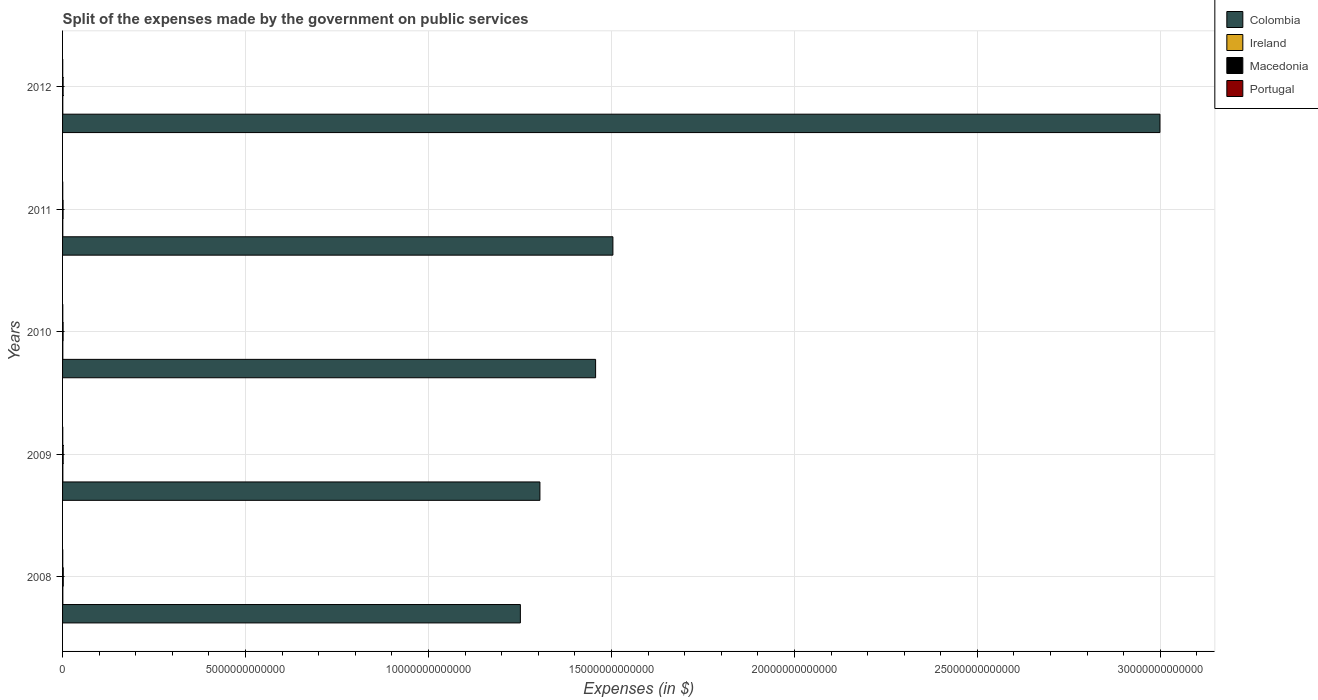Are the number of bars per tick equal to the number of legend labels?
Keep it short and to the point. Yes. How many bars are there on the 1st tick from the top?
Your answer should be very brief. 4. How many bars are there on the 3rd tick from the bottom?
Ensure brevity in your answer.  4. What is the label of the 2nd group of bars from the top?
Ensure brevity in your answer.  2011. In how many cases, is the number of bars for a given year not equal to the number of legend labels?
Keep it short and to the point. 0. What is the expenses made by the government on public services in Colombia in 2009?
Keep it short and to the point. 1.30e+13. Across all years, what is the maximum expenses made by the government on public services in Ireland?
Give a very brief answer. 7.87e+09. Across all years, what is the minimum expenses made by the government on public services in Colombia?
Your response must be concise. 1.25e+13. What is the total expenses made by the government on public services in Portugal in the graph?
Your answer should be very brief. 2.66e+1. What is the difference between the expenses made by the government on public services in Ireland in 2009 and that in 2011?
Provide a short and direct response. 1.45e+09. What is the difference between the expenses made by the government on public services in Ireland in 2009 and the expenses made by the government on public services in Colombia in 2012?
Make the answer very short. -3.00e+13. What is the average expenses made by the government on public services in Portugal per year?
Provide a short and direct response. 5.31e+09. In the year 2012, what is the difference between the expenses made by the government on public services in Colombia and expenses made by the government on public services in Macedonia?
Offer a very short reply. 3.00e+13. In how many years, is the expenses made by the government on public services in Portugal greater than 12000000000000 $?
Make the answer very short. 0. What is the ratio of the expenses made by the government on public services in Colombia in 2010 to that in 2011?
Provide a succinct answer. 0.97. What is the difference between the highest and the second highest expenses made by the government on public services in Portugal?
Ensure brevity in your answer.  6.00e+08. What is the difference between the highest and the lowest expenses made by the government on public services in Macedonia?
Make the answer very short. 4.79e+09. In how many years, is the expenses made by the government on public services in Portugal greater than the average expenses made by the government on public services in Portugal taken over all years?
Give a very brief answer. 2. Is the sum of the expenses made by the government on public services in Macedonia in 2008 and 2011 greater than the maximum expenses made by the government on public services in Colombia across all years?
Offer a terse response. No. Is it the case that in every year, the sum of the expenses made by the government on public services in Macedonia and expenses made by the government on public services in Colombia is greater than the sum of expenses made by the government on public services in Ireland and expenses made by the government on public services in Portugal?
Provide a succinct answer. Yes. What does the 4th bar from the bottom in 2009 represents?
Offer a terse response. Portugal. Is it the case that in every year, the sum of the expenses made by the government on public services in Colombia and expenses made by the government on public services in Ireland is greater than the expenses made by the government on public services in Macedonia?
Ensure brevity in your answer.  Yes. How many bars are there?
Provide a short and direct response. 20. Are all the bars in the graph horizontal?
Ensure brevity in your answer.  Yes. What is the difference between two consecutive major ticks on the X-axis?
Make the answer very short. 5.00e+12. Are the values on the major ticks of X-axis written in scientific E-notation?
Your answer should be compact. No. Does the graph contain any zero values?
Give a very brief answer. No. Does the graph contain grids?
Offer a very short reply. Yes. How many legend labels are there?
Your answer should be compact. 4. How are the legend labels stacked?
Your answer should be very brief. Vertical. What is the title of the graph?
Provide a short and direct response. Split of the expenses made by the government on public services. Does "Portugal" appear as one of the legend labels in the graph?
Provide a short and direct response. Yes. What is the label or title of the X-axis?
Keep it short and to the point. Expenses (in $). What is the Expenses (in $) of Colombia in 2008?
Give a very brief answer. 1.25e+13. What is the Expenses (in $) of Ireland in 2008?
Give a very brief answer. 7.59e+09. What is the Expenses (in $) of Macedonia in 2008?
Offer a very short reply. 1.87e+1. What is the Expenses (in $) of Portugal in 2008?
Your response must be concise. 4.99e+09. What is the Expenses (in $) of Colombia in 2009?
Your answer should be very brief. 1.30e+13. What is the Expenses (in $) in Ireland in 2009?
Your answer should be compact. 7.87e+09. What is the Expenses (in $) in Macedonia in 2009?
Keep it short and to the point. 1.62e+1. What is the Expenses (in $) of Portugal in 2009?
Offer a very short reply. 5.51e+09. What is the Expenses (in $) in Colombia in 2010?
Your response must be concise. 1.46e+13. What is the Expenses (in $) of Ireland in 2010?
Give a very brief answer. 7.05e+09. What is the Expenses (in $) in Macedonia in 2010?
Ensure brevity in your answer.  1.47e+1. What is the Expenses (in $) in Portugal in 2010?
Provide a succinct answer. 6.12e+09. What is the Expenses (in $) of Colombia in 2011?
Provide a short and direct response. 1.50e+13. What is the Expenses (in $) in Ireland in 2011?
Keep it short and to the point. 6.42e+09. What is the Expenses (in $) in Macedonia in 2011?
Ensure brevity in your answer.  1.40e+1. What is the Expenses (in $) of Portugal in 2011?
Make the answer very short. 5.18e+09. What is the Expenses (in $) in Colombia in 2012?
Ensure brevity in your answer.  3.00e+13. What is the Expenses (in $) of Ireland in 2012?
Give a very brief answer. 6.16e+09. What is the Expenses (in $) of Macedonia in 2012?
Give a very brief answer. 1.47e+1. What is the Expenses (in $) in Portugal in 2012?
Ensure brevity in your answer.  4.76e+09. Across all years, what is the maximum Expenses (in $) in Colombia?
Give a very brief answer. 3.00e+13. Across all years, what is the maximum Expenses (in $) of Ireland?
Make the answer very short. 7.87e+09. Across all years, what is the maximum Expenses (in $) of Macedonia?
Provide a succinct answer. 1.87e+1. Across all years, what is the maximum Expenses (in $) of Portugal?
Make the answer very short. 6.12e+09. Across all years, what is the minimum Expenses (in $) of Colombia?
Your response must be concise. 1.25e+13. Across all years, what is the minimum Expenses (in $) of Ireland?
Your response must be concise. 6.16e+09. Across all years, what is the minimum Expenses (in $) in Macedonia?
Ensure brevity in your answer.  1.40e+1. Across all years, what is the minimum Expenses (in $) in Portugal?
Offer a very short reply. 4.76e+09. What is the total Expenses (in $) in Colombia in the graph?
Your response must be concise. 8.52e+13. What is the total Expenses (in $) in Ireland in the graph?
Give a very brief answer. 3.51e+1. What is the total Expenses (in $) in Macedonia in the graph?
Offer a very short reply. 7.83e+1. What is the total Expenses (in $) of Portugal in the graph?
Your response must be concise. 2.66e+1. What is the difference between the Expenses (in $) of Colombia in 2008 and that in 2009?
Make the answer very short. -5.34e+11. What is the difference between the Expenses (in $) of Ireland in 2008 and that in 2009?
Provide a short and direct response. -2.79e+08. What is the difference between the Expenses (in $) of Macedonia in 2008 and that in 2009?
Offer a terse response. 2.52e+09. What is the difference between the Expenses (in $) in Portugal in 2008 and that in 2009?
Make the answer very short. -5.27e+08. What is the difference between the Expenses (in $) of Colombia in 2008 and that in 2010?
Give a very brief answer. -2.06e+12. What is the difference between the Expenses (in $) in Ireland in 2008 and that in 2010?
Your response must be concise. 5.35e+08. What is the difference between the Expenses (in $) in Macedonia in 2008 and that in 2010?
Your response must be concise. 4.06e+09. What is the difference between the Expenses (in $) of Portugal in 2008 and that in 2010?
Keep it short and to the point. -1.13e+09. What is the difference between the Expenses (in $) in Colombia in 2008 and that in 2011?
Offer a terse response. -2.53e+12. What is the difference between the Expenses (in $) of Ireland in 2008 and that in 2011?
Provide a short and direct response. 1.17e+09. What is the difference between the Expenses (in $) in Macedonia in 2008 and that in 2011?
Give a very brief answer. 4.79e+09. What is the difference between the Expenses (in $) in Portugal in 2008 and that in 2011?
Give a very brief answer. -1.91e+08. What is the difference between the Expenses (in $) of Colombia in 2008 and that in 2012?
Provide a succinct answer. -1.75e+13. What is the difference between the Expenses (in $) of Ireland in 2008 and that in 2012?
Your answer should be compact. 1.43e+09. What is the difference between the Expenses (in $) in Macedonia in 2008 and that in 2012?
Your response must be concise. 4.09e+09. What is the difference between the Expenses (in $) in Portugal in 2008 and that in 2012?
Make the answer very short. 2.23e+08. What is the difference between the Expenses (in $) in Colombia in 2009 and that in 2010?
Offer a very short reply. -1.52e+12. What is the difference between the Expenses (in $) of Ireland in 2009 and that in 2010?
Provide a succinct answer. 8.15e+08. What is the difference between the Expenses (in $) of Macedonia in 2009 and that in 2010?
Provide a short and direct response. 1.54e+09. What is the difference between the Expenses (in $) of Portugal in 2009 and that in 2010?
Your response must be concise. -6.00e+08. What is the difference between the Expenses (in $) of Colombia in 2009 and that in 2011?
Provide a succinct answer. -1.99e+12. What is the difference between the Expenses (in $) of Ireland in 2009 and that in 2011?
Keep it short and to the point. 1.45e+09. What is the difference between the Expenses (in $) in Macedonia in 2009 and that in 2011?
Offer a very short reply. 2.26e+09. What is the difference between the Expenses (in $) in Portugal in 2009 and that in 2011?
Offer a very short reply. 3.36e+08. What is the difference between the Expenses (in $) in Colombia in 2009 and that in 2012?
Offer a very short reply. -1.69e+13. What is the difference between the Expenses (in $) in Ireland in 2009 and that in 2012?
Keep it short and to the point. 1.71e+09. What is the difference between the Expenses (in $) in Macedonia in 2009 and that in 2012?
Your response must be concise. 1.57e+09. What is the difference between the Expenses (in $) in Portugal in 2009 and that in 2012?
Your answer should be compact. 7.51e+08. What is the difference between the Expenses (in $) in Colombia in 2010 and that in 2011?
Your response must be concise. -4.73e+11. What is the difference between the Expenses (in $) in Ireland in 2010 and that in 2011?
Keep it short and to the point. 6.31e+08. What is the difference between the Expenses (in $) in Macedonia in 2010 and that in 2011?
Offer a very short reply. 7.23e+08. What is the difference between the Expenses (in $) in Portugal in 2010 and that in 2011?
Ensure brevity in your answer.  9.36e+08. What is the difference between the Expenses (in $) in Colombia in 2010 and that in 2012?
Your response must be concise. -1.54e+13. What is the difference between the Expenses (in $) of Ireland in 2010 and that in 2012?
Keep it short and to the point. 8.94e+08. What is the difference between the Expenses (in $) in Macedonia in 2010 and that in 2012?
Provide a short and direct response. 2.90e+07. What is the difference between the Expenses (in $) in Portugal in 2010 and that in 2012?
Provide a short and direct response. 1.35e+09. What is the difference between the Expenses (in $) of Colombia in 2011 and that in 2012?
Ensure brevity in your answer.  -1.49e+13. What is the difference between the Expenses (in $) of Ireland in 2011 and that in 2012?
Keep it short and to the point. 2.63e+08. What is the difference between the Expenses (in $) in Macedonia in 2011 and that in 2012?
Offer a very short reply. -6.94e+08. What is the difference between the Expenses (in $) of Portugal in 2011 and that in 2012?
Offer a very short reply. 4.15e+08. What is the difference between the Expenses (in $) of Colombia in 2008 and the Expenses (in $) of Ireland in 2009?
Offer a terse response. 1.25e+13. What is the difference between the Expenses (in $) of Colombia in 2008 and the Expenses (in $) of Macedonia in 2009?
Make the answer very short. 1.25e+13. What is the difference between the Expenses (in $) in Colombia in 2008 and the Expenses (in $) in Portugal in 2009?
Make the answer very short. 1.25e+13. What is the difference between the Expenses (in $) in Ireland in 2008 and the Expenses (in $) in Macedonia in 2009?
Provide a short and direct response. -8.63e+09. What is the difference between the Expenses (in $) in Ireland in 2008 and the Expenses (in $) in Portugal in 2009?
Your answer should be compact. 2.07e+09. What is the difference between the Expenses (in $) in Macedonia in 2008 and the Expenses (in $) in Portugal in 2009?
Ensure brevity in your answer.  1.32e+1. What is the difference between the Expenses (in $) of Colombia in 2008 and the Expenses (in $) of Ireland in 2010?
Make the answer very short. 1.25e+13. What is the difference between the Expenses (in $) of Colombia in 2008 and the Expenses (in $) of Macedonia in 2010?
Provide a succinct answer. 1.25e+13. What is the difference between the Expenses (in $) of Colombia in 2008 and the Expenses (in $) of Portugal in 2010?
Provide a succinct answer. 1.25e+13. What is the difference between the Expenses (in $) of Ireland in 2008 and the Expenses (in $) of Macedonia in 2010?
Ensure brevity in your answer.  -7.10e+09. What is the difference between the Expenses (in $) of Ireland in 2008 and the Expenses (in $) of Portugal in 2010?
Keep it short and to the point. 1.47e+09. What is the difference between the Expenses (in $) in Macedonia in 2008 and the Expenses (in $) in Portugal in 2010?
Give a very brief answer. 1.26e+1. What is the difference between the Expenses (in $) in Colombia in 2008 and the Expenses (in $) in Ireland in 2011?
Your answer should be compact. 1.25e+13. What is the difference between the Expenses (in $) of Colombia in 2008 and the Expenses (in $) of Macedonia in 2011?
Provide a succinct answer. 1.25e+13. What is the difference between the Expenses (in $) in Colombia in 2008 and the Expenses (in $) in Portugal in 2011?
Make the answer very short. 1.25e+13. What is the difference between the Expenses (in $) in Ireland in 2008 and the Expenses (in $) in Macedonia in 2011?
Provide a succinct answer. -6.37e+09. What is the difference between the Expenses (in $) of Ireland in 2008 and the Expenses (in $) of Portugal in 2011?
Make the answer very short. 2.41e+09. What is the difference between the Expenses (in $) of Macedonia in 2008 and the Expenses (in $) of Portugal in 2011?
Your answer should be very brief. 1.36e+1. What is the difference between the Expenses (in $) of Colombia in 2008 and the Expenses (in $) of Ireland in 2012?
Your answer should be compact. 1.25e+13. What is the difference between the Expenses (in $) of Colombia in 2008 and the Expenses (in $) of Macedonia in 2012?
Provide a short and direct response. 1.25e+13. What is the difference between the Expenses (in $) of Colombia in 2008 and the Expenses (in $) of Portugal in 2012?
Offer a very short reply. 1.25e+13. What is the difference between the Expenses (in $) of Ireland in 2008 and the Expenses (in $) of Macedonia in 2012?
Provide a short and direct response. -7.07e+09. What is the difference between the Expenses (in $) of Ireland in 2008 and the Expenses (in $) of Portugal in 2012?
Your answer should be compact. 2.82e+09. What is the difference between the Expenses (in $) in Macedonia in 2008 and the Expenses (in $) in Portugal in 2012?
Make the answer very short. 1.40e+1. What is the difference between the Expenses (in $) of Colombia in 2009 and the Expenses (in $) of Ireland in 2010?
Give a very brief answer. 1.30e+13. What is the difference between the Expenses (in $) in Colombia in 2009 and the Expenses (in $) in Macedonia in 2010?
Offer a very short reply. 1.30e+13. What is the difference between the Expenses (in $) of Colombia in 2009 and the Expenses (in $) of Portugal in 2010?
Offer a terse response. 1.30e+13. What is the difference between the Expenses (in $) in Ireland in 2009 and the Expenses (in $) in Macedonia in 2010?
Give a very brief answer. -6.82e+09. What is the difference between the Expenses (in $) of Ireland in 2009 and the Expenses (in $) of Portugal in 2010?
Offer a very short reply. 1.75e+09. What is the difference between the Expenses (in $) of Macedonia in 2009 and the Expenses (in $) of Portugal in 2010?
Your response must be concise. 1.01e+1. What is the difference between the Expenses (in $) of Colombia in 2009 and the Expenses (in $) of Ireland in 2011?
Your answer should be very brief. 1.30e+13. What is the difference between the Expenses (in $) in Colombia in 2009 and the Expenses (in $) in Macedonia in 2011?
Your answer should be very brief. 1.30e+13. What is the difference between the Expenses (in $) of Colombia in 2009 and the Expenses (in $) of Portugal in 2011?
Your answer should be compact. 1.30e+13. What is the difference between the Expenses (in $) in Ireland in 2009 and the Expenses (in $) in Macedonia in 2011?
Ensure brevity in your answer.  -6.09e+09. What is the difference between the Expenses (in $) of Ireland in 2009 and the Expenses (in $) of Portugal in 2011?
Your response must be concise. 2.69e+09. What is the difference between the Expenses (in $) of Macedonia in 2009 and the Expenses (in $) of Portugal in 2011?
Keep it short and to the point. 1.10e+1. What is the difference between the Expenses (in $) in Colombia in 2009 and the Expenses (in $) in Ireland in 2012?
Give a very brief answer. 1.30e+13. What is the difference between the Expenses (in $) of Colombia in 2009 and the Expenses (in $) of Macedonia in 2012?
Offer a very short reply. 1.30e+13. What is the difference between the Expenses (in $) in Colombia in 2009 and the Expenses (in $) in Portugal in 2012?
Provide a succinct answer. 1.30e+13. What is the difference between the Expenses (in $) in Ireland in 2009 and the Expenses (in $) in Macedonia in 2012?
Your answer should be very brief. -6.79e+09. What is the difference between the Expenses (in $) of Ireland in 2009 and the Expenses (in $) of Portugal in 2012?
Your answer should be compact. 3.10e+09. What is the difference between the Expenses (in $) in Macedonia in 2009 and the Expenses (in $) in Portugal in 2012?
Provide a short and direct response. 1.15e+1. What is the difference between the Expenses (in $) in Colombia in 2010 and the Expenses (in $) in Ireland in 2011?
Give a very brief answer. 1.46e+13. What is the difference between the Expenses (in $) in Colombia in 2010 and the Expenses (in $) in Macedonia in 2011?
Keep it short and to the point. 1.46e+13. What is the difference between the Expenses (in $) of Colombia in 2010 and the Expenses (in $) of Portugal in 2011?
Ensure brevity in your answer.  1.46e+13. What is the difference between the Expenses (in $) of Ireland in 2010 and the Expenses (in $) of Macedonia in 2011?
Keep it short and to the point. -6.91e+09. What is the difference between the Expenses (in $) of Ireland in 2010 and the Expenses (in $) of Portugal in 2011?
Offer a very short reply. 1.87e+09. What is the difference between the Expenses (in $) in Macedonia in 2010 and the Expenses (in $) in Portugal in 2011?
Offer a terse response. 9.50e+09. What is the difference between the Expenses (in $) in Colombia in 2010 and the Expenses (in $) in Ireland in 2012?
Your answer should be very brief. 1.46e+13. What is the difference between the Expenses (in $) in Colombia in 2010 and the Expenses (in $) in Macedonia in 2012?
Provide a short and direct response. 1.46e+13. What is the difference between the Expenses (in $) in Colombia in 2010 and the Expenses (in $) in Portugal in 2012?
Offer a very short reply. 1.46e+13. What is the difference between the Expenses (in $) of Ireland in 2010 and the Expenses (in $) of Macedonia in 2012?
Give a very brief answer. -7.60e+09. What is the difference between the Expenses (in $) in Ireland in 2010 and the Expenses (in $) in Portugal in 2012?
Your response must be concise. 2.29e+09. What is the difference between the Expenses (in $) of Macedonia in 2010 and the Expenses (in $) of Portugal in 2012?
Keep it short and to the point. 9.92e+09. What is the difference between the Expenses (in $) in Colombia in 2011 and the Expenses (in $) in Ireland in 2012?
Your answer should be very brief. 1.50e+13. What is the difference between the Expenses (in $) in Colombia in 2011 and the Expenses (in $) in Macedonia in 2012?
Ensure brevity in your answer.  1.50e+13. What is the difference between the Expenses (in $) of Colombia in 2011 and the Expenses (in $) of Portugal in 2012?
Make the answer very short. 1.50e+13. What is the difference between the Expenses (in $) in Ireland in 2011 and the Expenses (in $) in Macedonia in 2012?
Offer a very short reply. -8.23e+09. What is the difference between the Expenses (in $) in Ireland in 2011 and the Expenses (in $) in Portugal in 2012?
Ensure brevity in your answer.  1.66e+09. What is the difference between the Expenses (in $) in Macedonia in 2011 and the Expenses (in $) in Portugal in 2012?
Provide a short and direct response. 9.19e+09. What is the average Expenses (in $) in Colombia per year?
Provide a succinct answer. 1.70e+13. What is the average Expenses (in $) in Ireland per year?
Your answer should be compact. 7.02e+09. What is the average Expenses (in $) in Macedonia per year?
Provide a succinct answer. 1.57e+1. What is the average Expenses (in $) in Portugal per year?
Offer a very short reply. 5.31e+09. In the year 2008, what is the difference between the Expenses (in $) in Colombia and Expenses (in $) in Ireland?
Your answer should be compact. 1.25e+13. In the year 2008, what is the difference between the Expenses (in $) of Colombia and Expenses (in $) of Macedonia?
Provide a succinct answer. 1.25e+13. In the year 2008, what is the difference between the Expenses (in $) of Colombia and Expenses (in $) of Portugal?
Your answer should be very brief. 1.25e+13. In the year 2008, what is the difference between the Expenses (in $) in Ireland and Expenses (in $) in Macedonia?
Provide a short and direct response. -1.12e+1. In the year 2008, what is the difference between the Expenses (in $) of Ireland and Expenses (in $) of Portugal?
Give a very brief answer. 2.60e+09. In the year 2008, what is the difference between the Expenses (in $) in Macedonia and Expenses (in $) in Portugal?
Give a very brief answer. 1.38e+1. In the year 2009, what is the difference between the Expenses (in $) of Colombia and Expenses (in $) of Ireland?
Offer a very short reply. 1.30e+13. In the year 2009, what is the difference between the Expenses (in $) in Colombia and Expenses (in $) in Macedonia?
Your answer should be compact. 1.30e+13. In the year 2009, what is the difference between the Expenses (in $) in Colombia and Expenses (in $) in Portugal?
Keep it short and to the point. 1.30e+13. In the year 2009, what is the difference between the Expenses (in $) in Ireland and Expenses (in $) in Macedonia?
Provide a succinct answer. -8.35e+09. In the year 2009, what is the difference between the Expenses (in $) of Ireland and Expenses (in $) of Portugal?
Give a very brief answer. 2.35e+09. In the year 2009, what is the difference between the Expenses (in $) of Macedonia and Expenses (in $) of Portugal?
Give a very brief answer. 1.07e+1. In the year 2010, what is the difference between the Expenses (in $) in Colombia and Expenses (in $) in Ireland?
Ensure brevity in your answer.  1.46e+13. In the year 2010, what is the difference between the Expenses (in $) of Colombia and Expenses (in $) of Macedonia?
Your answer should be very brief. 1.46e+13. In the year 2010, what is the difference between the Expenses (in $) of Colombia and Expenses (in $) of Portugal?
Give a very brief answer. 1.46e+13. In the year 2010, what is the difference between the Expenses (in $) of Ireland and Expenses (in $) of Macedonia?
Your answer should be very brief. -7.63e+09. In the year 2010, what is the difference between the Expenses (in $) of Ireland and Expenses (in $) of Portugal?
Offer a very short reply. 9.35e+08. In the year 2010, what is the difference between the Expenses (in $) in Macedonia and Expenses (in $) in Portugal?
Provide a succinct answer. 8.57e+09. In the year 2011, what is the difference between the Expenses (in $) in Colombia and Expenses (in $) in Ireland?
Ensure brevity in your answer.  1.50e+13. In the year 2011, what is the difference between the Expenses (in $) in Colombia and Expenses (in $) in Macedonia?
Keep it short and to the point. 1.50e+13. In the year 2011, what is the difference between the Expenses (in $) of Colombia and Expenses (in $) of Portugal?
Make the answer very short. 1.50e+13. In the year 2011, what is the difference between the Expenses (in $) in Ireland and Expenses (in $) in Macedonia?
Your answer should be very brief. -7.54e+09. In the year 2011, what is the difference between the Expenses (in $) in Ireland and Expenses (in $) in Portugal?
Your answer should be very brief. 1.24e+09. In the year 2011, what is the difference between the Expenses (in $) in Macedonia and Expenses (in $) in Portugal?
Make the answer very short. 8.78e+09. In the year 2012, what is the difference between the Expenses (in $) of Colombia and Expenses (in $) of Ireland?
Offer a very short reply. 3.00e+13. In the year 2012, what is the difference between the Expenses (in $) in Colombia and Expenses (in $) in Macedonia?
Offer a very short reply. 3.00e+13. In the year 2012, what is the difference between the Expenses (in $) of Colombia and Expenses (in $) of Portugal?
Ensure brevity in your answer.  3.00e+13. In the year 2012, what is the difference between the Expenses (in $) in Ireland and Expenses (in $) in Macedonia?
Offer a terse response. -8.50e+09. In the year 2012, what is the difference between the Expenses (in $) of Ireland and Expenses (in $) of Portugal?
Your answer should be compact. 1.39e+09. In the year 2012, what is the difference between the Expenses (in $) of Macedonia and Expenses (in $) of Portugal?
Offer a terse response. 9.89e+09. What is the ratio of the Expenses (in $) of Colombia in 2008 to that in 2009?
Give a very brief answer. 0.96. What is the ratio of the Expenses (in $) of Ireland in 2008 to that in 2009?
Provide a short and direct response. 0.96. What is the ratio of the Expenses (in $) of Macedonia in 2008 to that in 2009?
Your answer should be compact. 1.16. What is the ratio of the Expenses (in $) of Portugal in 2008 to that in 2009?
Make the answer very short. 0.9. What is the ratio of the Expenses (in $) of Colombia in 2008 to that in 2010?
Offer a very short reply. 0.86. What is the ratio of the Expenses (in $) of Ireland in 2008 to that in 2010?
Keep it short and to the point. 1.08. What is the ratio of the Expenses (in $) in Macedonia in 2008 to that in 2010?
Provide a short and direct response. 1.28. What is the ratio of the Expenses (in $) of Portugal in 2008 to that in 2010?
Offer a terse response. 0.82. What is the ratio of the Expenses (in $) of Colombia in 2008 to that in 2011?
Your response must be concise. 0.83. What is the ratio of the Expenses (in $) in Ireland in 2008 to that in 2011?
Keep it short and to the point. 1.18. What is the ratio of the Expenses (in $) of Macedonia in 2008 to that in 2011?
Keep it short and to the point. 1.34. What is the ratio of the Expenses (in $) of Portugal in 2008 to that in 2011?
Offer a very short reply. 0.96. What is the ratio of the Expenses (in $) of Colombia in 2008 to that in 2012?
Your answer should be very brief. 0.42. What is the ratio of the Expenses (in $) in Ireland in 2008 to that in 2012?
Your response must be concise. 1.23. What is the ratio of the Expenses (in $) in Macedonia in 2008 to that in 2012?
Offer a terse response. 1.28. What is the ratio of the Expenses (in $) in Portugal in 2008 to that in 2012?
Provide a short and direct response. 1.05. What is the ratio of the Expenses (in $) of Colombia in 2009 to that in 2010?
Provide a succinct answer. 0.9. What is the ratio of the Expenses (in $) in Ireland in 2009 to that in 2010?
Your response must be concise. 1.12. What is the ratio of the Expenses (in $) of Macedonia in 2009 to that in 2010?
Give a very brief answer. 1.1. What is the ratio of the Expenses (in $) of Portugal in 2009 to that in 2010?
Make the answer very short. 0.9. What is the ratio of the Expenses (in $) in Colombia in 2009 to that in 2011?
Keep it short and to the point. 0.87. What is the ratio of the Expenses (in $) of Ireland in 2009 to that in 2011?
Your response must be concise. 1.23. What is the ratio of the Expenses (in $) in Macedonia in 2009 to that in 2011?
Ensure brevity in your answer.  1.16. What is the ratio of the Expenses (in $) in Portugal in 2009 to that in 2011?
Ensure brevity in your answer.  1.06. What is the ratio of the Expenses (in $) in Colombia in 2009 to that in 2012?
Provide a succinct answer. 0.43. What is the ratio of the Expenses (in $) of Ireland in 2009 to that in 2012?
Your response must be concise. 1.28. What is the ratio of the Expenses (in $) in Macedonia in 2009 to that in 2012?
Your answer should be very brief. 1.11. What is the ratio of the Expenses (in $) of Portugal in 2009 to that in 2012?
Keep it short and to the point. 1.16. What is the ratio of the Expenses (in $) of Colombia in 2010 to that in 2011?
Provide a short and direct response. 0.97. What is the ratio of the Expenses (in $) of Ireland in 2010 to that in 2011?
Your answer should be compact. 1.1. What is the ratio of the Expenses (in $) in Macedonia in 2010 to that in 2011?
Give a very brief answer. 1.05. What is the ratio of the Expenses (in $) of Portugal in 2010 to that in 2011?
Ensure brevity in your answer.  1.18. What is the ratio of the Expenses (in $) in Colombia in 2010 to that in 2012?
Provide a succinct answer. 0.49. What is the ratio of the Expenses (in $) in Ireland in 2010 to that in 2012?
Provide a succinct answer. 1.15. What is the ratio of the Expenses (in $) of Macedonia in 2010 to that in 2012?
Provide a succinct answer. 1. What is the ratio of the Expenses (in $) in Portugal in 2010 to that in 2012?
Your response must be concise. 1.28. What is the ratio of the Expenses (in $) in Colombia in 2011 to that in 2012?
Provide a short and direct response. 0.5. What is the ratio of the Expenses (in $) in Ireland in 2011 to that in 2012?
Provide a succinct answer. 1.04. What is the ratio of the Expenses (in $) in Macedonia in 2011 to that in 2012?
Provide a succinct answer. 0.95. What is the ratio of the Expenses (in $) of Portugal in 2011 to that in 2012?
Offer a very short reply. 1.09. What is the difference between the highest and the second highest Expenses (in $) of Colombia?
Your answer should be compact. 1.49e+13. What is the difference between the highest and the second highest Expenses (in $) in Ireland?
Offer a terse response. 2.79e+08. What is the difference between the highest and the second highest Expenses (in $) in Macedonia?
Provide a succinct answer. 2.52e+09. What is the difference between the highest and the second highest Expenses (in $) of Portugal?
Keep it short and to the point. 6.00e+08. What is the difference between the highest and the lowest Expenses (in $) in Colombia?
Offer a very short reply. 1.75e+13. What is the difference between the highest and the lowest Expenses (in $) of Ireland?
Keep it short and to the point. 1.71e+09. What is the difference between the highest and the lowest Expenses (in $) of Macedonia?
Your response must be concise. 4.79e+09. What is the difference between the highest and the lowest Expenses (in $) of Portugal?
Offer a very short reply. 1.35e+09. 